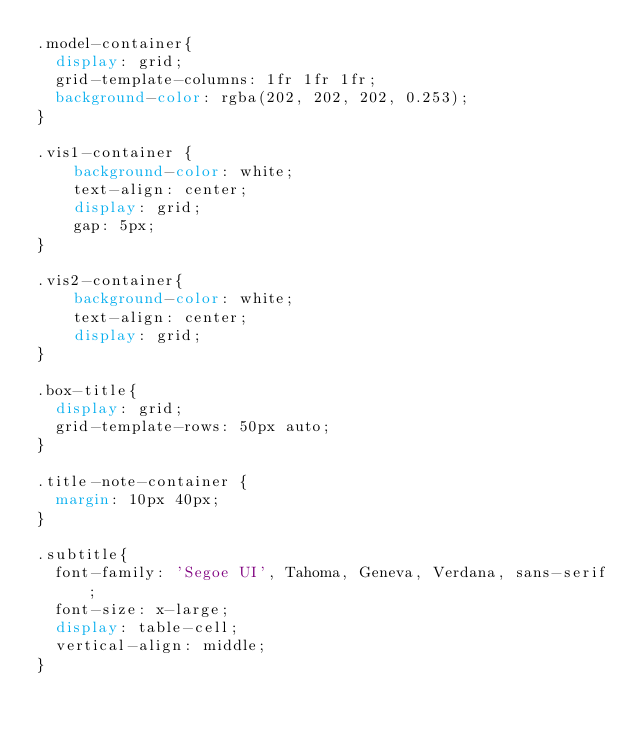Convert code to text. <code><loc_0><loc_0><loc_500><loc_500><_CSS_>.model-container{
  display: grid;
  grid-template-columns: 1fr 1fr 1fr;
  background-color: rgba(202, 202, 202, 0.253);
}

.vis1-container {
    background-color: white;
    text-align: center;
    display: grid;
    gap: 5px;
}

.vis2-container{
    background-color: white;
    text-align: center;
    display: grid;
}

.box-title{
  display: grid;
  grid-template-rows: 50px auto;
}

.title-note-container {
  margin: 10px 40px;
}

.subtitle{
  font-family: 'Segoe UI', Tahoma, Geneva, Verdana, sans-serif;
  font-size: x-large;
  display: table-cell;
  vertical-align: middle;
}
</code> 